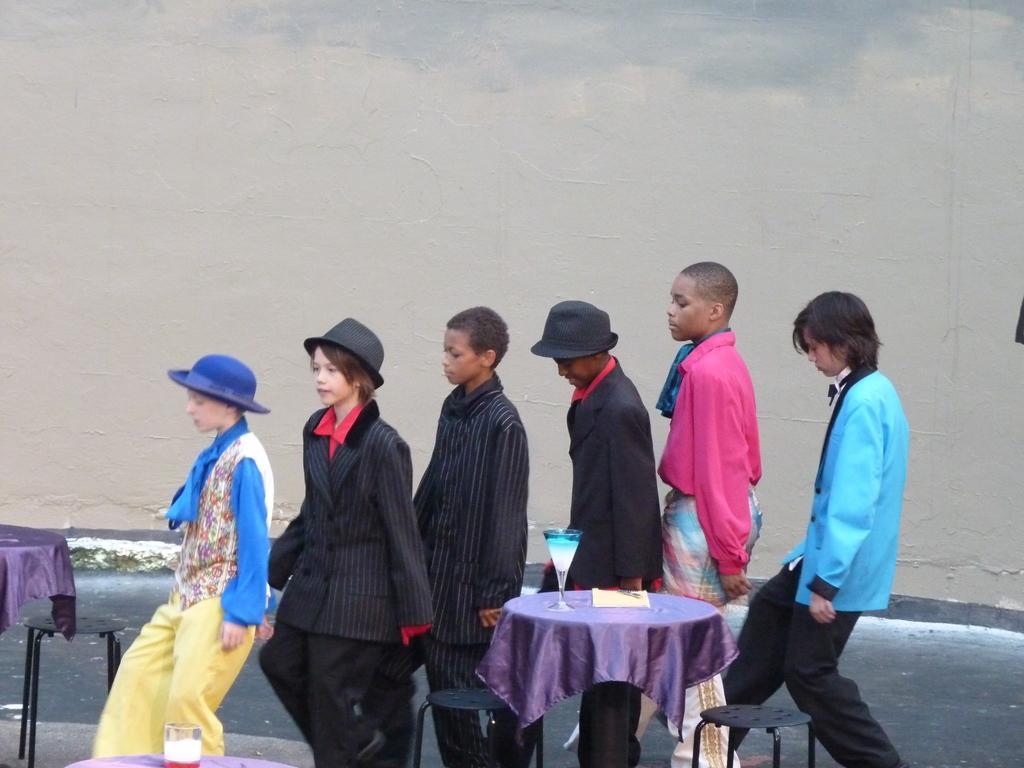What are the people doing in the image? The people are on a path in the image. What objects are on the tables in the image? There are glasses and a card on the tables. What type of furniture is present in the image? There are chairs in the image. What can be seen in the background of the image? A wall is visible in the background of the image. What is the tendency of the bikes to move around in the image? There are no bikes present in the image, so it is not possible to determine any tendency for them to move around. 